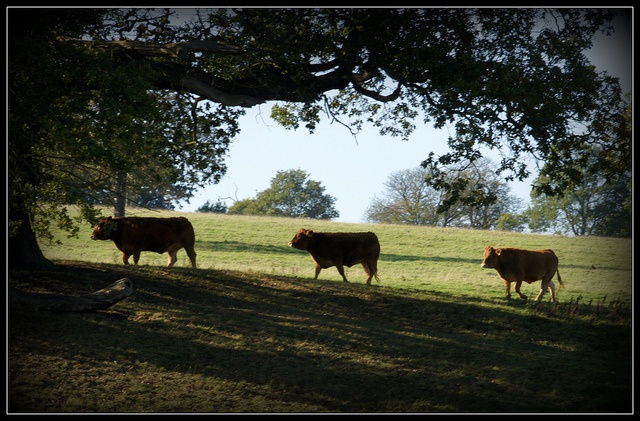Describe the objects in this image and their specific colors. I can see cow in black, maroon, olive, and tan tones, cow in black, olive, maroon, and brown tones, and cow in black, olive, and maroon tones in this image. 